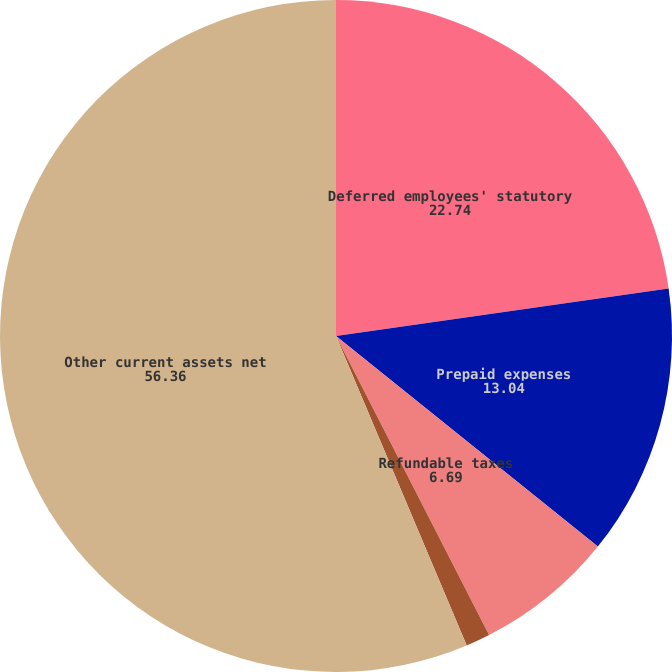<chart> <loc_0><loc_0><loc_500><loc_500><pie_chart><fcel>Deferred employees' statutory<fcel>Prepaid expenses<fcel>Refundable taxes<fcel>Other<fcel>Other current assets net<nl><fcel>22.74%<fcel>13.04%<fcel>6.69%<fcel>1.17%<fcel>56.36%<nl></chart> 